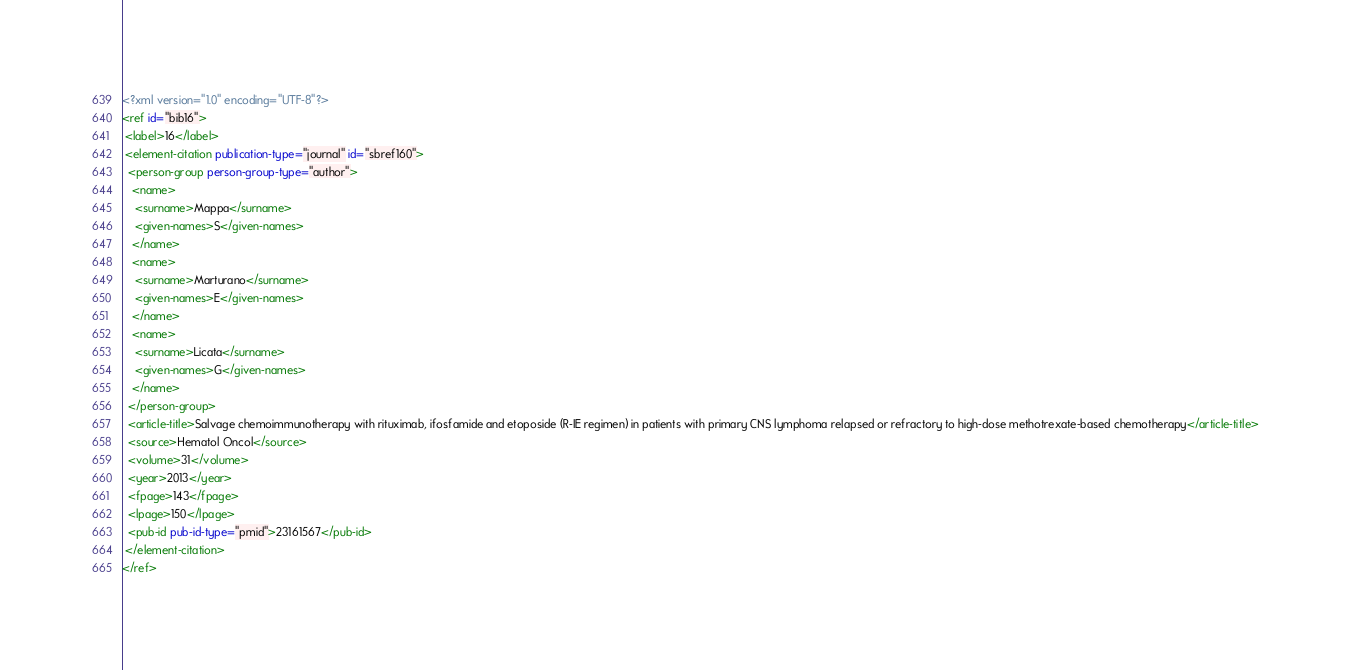<code> <loc_0><loc_0><loc_500><loc_500><_XML_><?xml version="1.0" encoding="UTF-8"?>
<ref id="bib16">
 <label>16</label>
 <element-citation publication-type="journal" id="sbref160">
  <person-group person-group-type="author">
   <name>
    <surname>Mappa</surname>
    <given-names>S</given-names>
   </name>
   <name>
    <surname>Marturano</surname>
    <given-names>E</given-names>
   </name>
   <name>
    <surname>Licata</surname>
    <given-names>G</given-names>
   </name>
  </person-group>
  <article-title>Salvage chemoimmunotherapy with rituximab, ifosfamide and etoposide (R-IE regimen) in patients with primary CNS lymphoma relapsed or refractory to high-dose methotrexate-based chemotherapy</article-title>
  <source>Hematol Oncol</source>
  <volume>31</volume>
  <year>2013</year>
  <fpage>143</fpage>
  <lpage>150</lpage>
  <pub-id pub-id-type="pmid">23161567</pub-id>
 </element-citation>
</ref>
</code> 